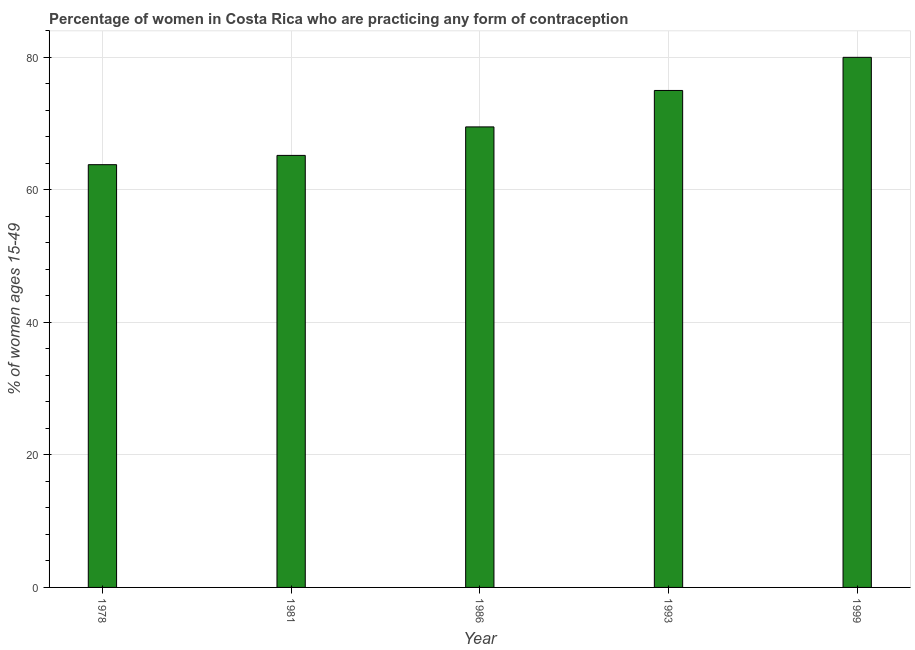Does the graph contain grids?
Ensure brevity in your answer.  Yes. What is the title of the graph?
Give a very brief answer. Percentage of women in Costa Rica who are practicing any form of contraception. What is the label or title of the X-axis?
Your answer should be very brief. Year. What is the label or title of the Y-axis?
Your answer should be very brief. % of women ages 15-49. Across all years, what is the maximum contraceptive prevalence?
Give a very brief answer. 80. Across all years, what is the minimum contraceptive prevalence?
Ensure brevity in your answer.  63.8. In which year was the contraceptive prevalence minimum?
Ensure brevity in your answer.  1978. What is the sum of the contraceptive prevalence?
Give a very brief answer. 353.5. What is the average contraceptive prevalence per year?
Your answer should be compact. 70.7. What is the median contraceptive prevalence?
Offer a very short reply. 69.5. Do a majority of the years between 1993 and 1981 (inclusive) have contraceptive prevalence greater than 64 %?
Give a very brief answer. Yes. What is the ratio of the contraceptive prevalence in 1978 to that in 1986?
Offer a very short reply. 0.92. Is the contraceptive prevalence in 1986 less than that in 1999?
Make the answer very short. Yes. Is the sum of the contraceptive prevalence in 1978 and 1993 greater than the maximum contraceptive prevalence across all years?
Offer a terse response. Yes. What is the difference between the highest and the lowest contraceptive prevalence?
Your response must be concise. 16.2. How many bars are there?
Provide a short and direct response. 5. What is the difference between two consecutive major ticks on the Y-axis?
Your answer should be compact. 20. Are the values on the major ticks of Y-axis written in scientific E-notation?
Your answer should be compact. No. What is the % of women ages 15-49 of 1978?
Your answer should be very brief. 63.8. What is the % of women ages 15-49 of 1981?
Your response must be concise. 65.2. What is the % of women ages 15-49 in 1986?
Ensure brevity in your answer.  69.5. What is the % of women ages 15-49 of 1993?
Provide a short and direct response. 75. What is the difference between the % of women ages 15-49 in 1978 and 1993?
Ensure brevity in your answer.  -11.2. What is the difference between the % of women ages 15-49 in 1978 and 1999?
Make the answer very short. -16.2. What is the difference between the % of women ages 15-49 in 1981 and 1999?
Your answer should be compact. -14.8. What is the ratio of the % of women ages 15-49 in 1978 to that in 1981?
Your answer should be compact. 0.98. What is the ratio of the % of women ages 15-49 in 1978 to that in 1986?
Offer a very short reply. 0.92. What is the ratio of the % of women ages 15-49 in 1978 to that in 1993?
Offer a terse response. 0.85. What is the ratio of the % of women ages 15-49 in 1978 to that in 1999?
Give a very brief answer. 0.8. What is the ratio of the % of women ages 15-49 in 1981 to that in 1986?
Give a very brief answer. 0.94. What is the ratio of the % of women ages 15-49 in 1981 to that in 1993?
Offer a terse response. 0.87. What is the ratio of the % of women ages 15-49 in 1981 to that in 1999?
Give a very brief answer. 0.81. What is the ratio of the % of women ages 15-49 in 1986 to that in 1993?
Your answer should be compact. 0.93. What is the ratio of the % of women ages 15-49 in 1986 to that in 1999?
Your answer should be very brief. 0.87. What is the ratio of the % of women ages 15-49 in 1993 to that in 1999?
Provide a succinct answer. 0.94. 